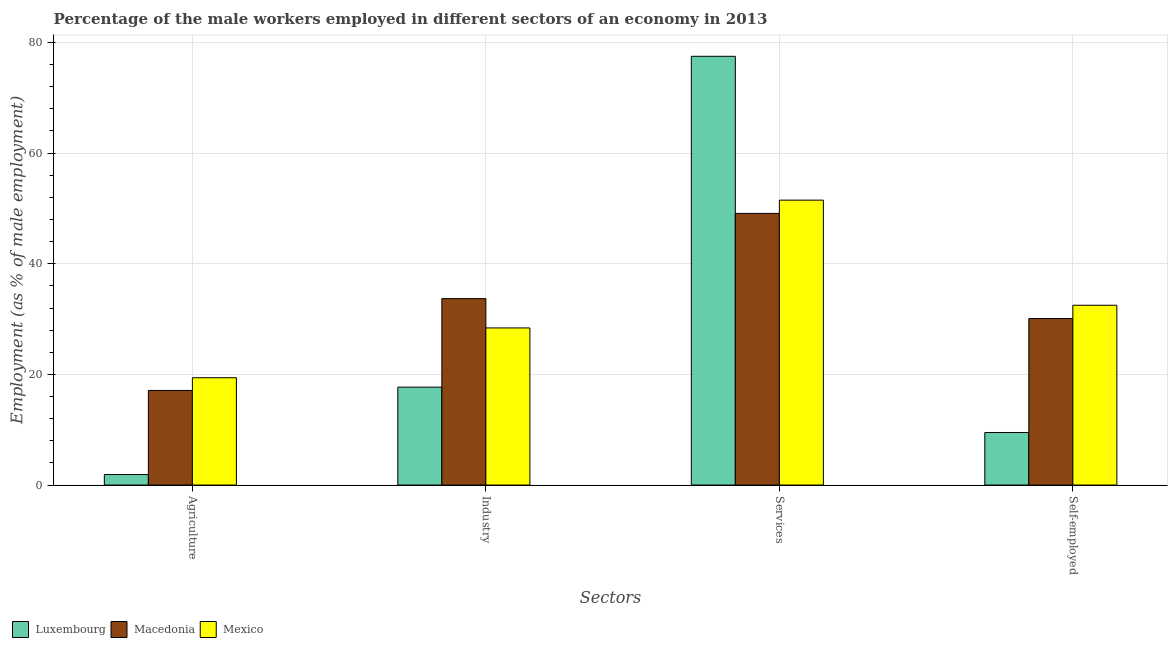How many different coloured bars are there?
Provide a short and direct response. 3. Are the number of bars per tick equal to the number of legend labels?
Your response must be concise. Yes. What is the label of the 2nd group of bars from the left?
Provide a succinct answer. Industry. Across all countries, what is the maximum percentage of male workers in services?
Offer a terse response. 77.5. Across all countries, what is the minimum percentage of male workers in services?
Offer a very short reply. 49.1. In which country was the percentage of male workers in services maximum?
Your response must be concise. Luxembourg. In which country was the percentage of self employed male workers minimum?
Provide a short and direct response. Luxembourg. What is the total percentage of male workers in services in the graph?
Provide a succinct answer. 178.1. What is the difference between the percentage of male workers in services in Luxembourg and that in Mexico?
Offer a very short reply. 26. What is the difference between the percentage of male workers in industry in Mexico and the percentage of male workers in services in Luxembourg?
Your answer should be very brief. -49.1. What is the average percentage of male workers in agriculture per country?
Provide a short and direct response. 12.8. What is the difference between the percentage of self employed male workers and percentage of male workers in industry in Luxembourg?
Offer a terse response. -8.2. In how many countries, is the percentage of male workers in agriculture greater than 40 %?
Give a very brief answer. 0. What is the ratio of the percentage of male workers in agriculture in Luxembourg to that in Macedonia?
Your answer should be compact. 0.11. Is the percentage of self employed male workers in Macedonia less than that in Mexico?
Offer a terse response. Yes. Is the difference between the percentage of male workers in services in Macedonia and Mexico greater than the difference between the percentage of male workers in agriculture in Macedonia and Mexico?
Provide a short and direct response. No. What is the difference between the highest and the second highest percentage of self employed male workers?
Ensure brevity in your answer.  2.4. What is the difference between the highest and the lowest percentage of male workers in industry?
Offer a very short reply. 16. Is the sum of the percentage of male workers in industry in Mexico and Macedonia greater than the maximum percentage of male workers in services across all countries?
Make the answer very short. No. Is it the case that in every country, the sum of the percentage of self employed male workers and percentage of male workers in agriculture is greater than the sum of percentage of male workers in services and percentage of male workers in industry?
Your answer should be compact. No. What does the 2nd bar from the left in Industry represents?
Your answer should be compact. Macedonia. What does the 3rd bar from the right in Agriculture represents?
Offer a very short reply. Luxembourg. Is it the case that in every country, the sum of the percentage of male workers in agriculture and percentage of male workers in industry is greater than the percentage of male workers in services?
Your answer should be compact. No. Are all the bars in the graph horizontal?
Give a very brief answer. No. How many countries are there in the graph?
Make the answer very short. 3. What is the difference between two consecutive major ticks on the Y-axis?
Ensure brevity in your answer.  20. Does the graph contain any zero values?
Give a very brief answer. No. How many legend labels are there?
Provide a short and direct response. 3. How are the legend labels stacked?
Your response must be concise. Horizontal. What is the title of the graph?
Offer a terse response. Percentage of the male workers employed in different sectors of an economy in 2013. What is the label or title of the X-axis?
Provide a short and direct response. Sectors. What is the label or title of the Y-axis?
Your response must be concise. Employment (as % of male employment). What is the Employment (as % of male employment) in Luxembourg in Agriculture?
Provide a short and direct response. 1.9. What is the Employment (as % of male employment) of Macedonia in Agriculture?
Offer a very short reply. 17.1. What is the Employment (as % of male employment) in Mexico in Agriculture?
Ensure brevity in your answer.  19.4. What is the Employment (as % of male employment) in Luxembourg in Industry?
Make the answer very short. 17.7. What is the Employment (as % of male employment) of Macedonia in Industry?
Make the answer very short. 33.7. What is the Employment (as % of male employment) of Mexico in Industry?
Your answer should be very brief. 28.4. What is the Employment (as % of male employment) in Luxembourg in Services?
Give a very brief answer. 77.5. What is the Employment (as % of male employment) in Macedonia in Services?
Give a very brief answer. 49.1. What is the Employment (as % of male employment) of Mexico in Services?
Offer a very short reply. 51.5. What is the Employment (as % of male employment) in Luxembourg in Self-employed?
Offer a very short reply. 9.5. What is the Employment (as % of male employment) in Macedonia in Self-employed?
Offer a terse response. 30.1. What is the Employment (as % of male employment) in Mexico in Self-employed?
Your response must be concise. 32.5. Across all Sectors, what is the maximum Employment (as % of male employment) in Luxembourg?
Ensure brevity in your answer.  77.5. Across all Sectors, what is the maximum Employment (as % of male employment) of Macedonia?
Keep it short and to the point. 49.1. Across all Sectors, what is the maximum Employment (as % of male employment) of Mexico?
Make the answer very short. 51.5. Across all Sectors, what is the minimum Employment (as % of male employment) in Luxembourg?
Ensure brevity in your answer.  1.9. Across all Sectors, what is the minimum Employment (as % of male employment) of Macedonia?
Ensure brevity in your answer.  17.1. Across all Sectors, what is the minimum Employment (as % of male employment) in Mexico?
Your response must be concise. 19.4. What is the total Employment (as % of male employment) in Luxembourg in the graph?
Keep it short and to the point. 106.6. What is the total Employment (as % of male employment) of Macedonia in the graph?
Provide a succinct answer. 130. What is the total Employment (as % of male employment) in Mexico in the graph?
Make the answer very short. 131.8. What is the difference between the Employment (as % of male employment) of Luxembourg in Agriculture and that in Industry?
Your answer should be compact. -15.8. What is the difference between the Employment (as % of male employment) in Macedonia in Agriculture and that in Industry?
Your answer should be very brief. -16.6. What is the difference between the Employment (as % of male employment) of Luxembourg in Agriculture and that in Services?
Provide a short and direct response. -75.6. What is the difference between the Employment (as % of male employment) of Macedonia in Agriculture and that in Services?
Provide a short and direct response. -32. What is the difference between the Employment (as % of male employment) in Mexico in Agriculture and that in Services?
Keep it short and to the point. -32.1. What is the difference between the Employment (as % of male employment) in Macedonia in Agriculture and that in Self-employed?
Make the answer very short. -13. What is the difference between the Employment (as % of male employment) in Luxembourg in Industry and that in Services?
Keep it short and to the point. -59.8. What is the difference between the Employment (as % of male employment) of Macedonia in Industry and that in Services?
Your response must be concise. -15.4. What is the difference between the Employment (as % of male employment) of Mexico in Industry and that in Services?
Your response must be concise. -23.1. What is the difference between the Employment (as % of male employment) of Luxembourg in Industry and that in Self-employed?
Offer a very short reply. 8.2. What is the difference between the Employment (as % of male employment) in Macedonia in Industry and that in Self-employed?
Ensure brevity in your answer.  3.6. What is the difference between the Employment (as % of male employment) in Luxembourg in Services and that in Self-employed?
Your response must be concise. 68. What is the difference between the Employment (as % of male employment) in Mexico in Services and that in Self-employed?
Your response must be concise. 19. What is the difference between the Employment (as % of male employment) of Luxembourg in Agriculture and the Employment (as % of male employment) of Macedonia in Industry?
Your answer should be very brief. -31.8. What is the difference between the Employment (as % of male employment) of Luxembourg in Agriculture and the Employment (as % of male employment) of Mexico in Industry?
Ensure brevity in your answer.  -26.5. What is the difference between the Employment (as % of male employment) of Macedonia in Agriculture and the Employment (as % of male employment) of Mexico in Industry?
Offer a very short reply. -11.3. What is the difference between the Employment (as % of male employment) in Luxembourg in Agriculture and the Employment (as % of male employment) in Macedonia in Services?
Your answer should be compact. -47.2. What is the difference between the Employment (as % of male employment) in Luxembourg in Agriculture and the Employment (as % of male employment) in Mexico in Services?
Give a very brief answer. -49.6. What is the difference between the Employment (as % of male employment) in Macedonia in Agriculture and the Employment (as % of male employment) in Mexico in Services?
Ensure brevity in your answer.  -34.4. What is the difference between the Employment (as % of male employment) in Luxembourg in Agriculture and the Employment (as % of male employment) in Macedonia in Self-employed?
Provide a short and direct response. -28.2. What is the difference between the Employment (as % of male employment) of Luxembourg in Agriculture and the Employment (as % of male employment) of Mexico in Self-employed?
Provide a succinct answer. -30.6. What is the difference between the Employment (as % of male employment) of Macedonia in Agriculture and the Employment (as % of male employment) of Mexico in Self-employed?
Your answer should be very brief. -15.4. What is the difference between the Employment (as % of male employment) of Luxembourg in Industry and the Employment (as % of male employment) of Macedonia in Services?
Provide a short and direct response. -31.4. What is the difference between the Employment (as % of male employment) of Luxembourg in Industry and the Employment (as % of male employment) of Mexico in Services?
Ensure brevity in your answer.  -33.8. What is the difference between the Employment (as % of male employment) in Macedonia in Industry and the Employment (as % of male employment) in Mexico in Services?
Your response must be concise. -17.8. What is the difference between the Employment (as % of male employment) of Luxembourg in Industry and the Employment (as % of male employment) of Macedonia in Self-employed?
Offer a very short reply. -12.4. What is the difference between the Employment (as % of male employment) in Luxembourg in Industry and the Employment (as % of male employment) in Mexico in Self-employed?
Offer a terse response. -14.8. What is the difference between the Employment (as % of male employment) in Macedonia in Industry and the Employment (as % of male employment) in Mexico in Self-employed?
Your response must be concise. 1.2. What is the difference between the Employment (as % of male employment) of Luxembourg in Services and the Employment (as % of male employment) of Macedonia in Self-employed?
Your answer should be very brief. 47.4. What is the difference between the Employment (as % of male employment) of Luxembourg in Services and the Employment (as % of male employment) of Mexico in Self-employed?
Give a very brief answer. 45. What is the average Employment (as % of male employment) in Luxembourg per Sectors?
Ensure brevity in your answer.  26.65. What is the average Employment (as % of male employment) of Macedonia per Sectors?
Provide a succinct answer. 32.5. What is the average Employment (as % of male employment) of Mexico per Sectors?
Your response must be concise. 32.95. What is the difference between the Employment (as % of male employment) of Luxembourg and Employment (as % of male employment) of Macedonia in Agriculture?
Offer a very short reply. -15.2. What is the difference between the Employment (as % of male employment) of Luxembourg and Employment (as % of male employment) of Mexico in Agriculture?
Make the answer very short. -17.5. What is the difference between the Employment (as % of male employment) in Luxembourg and Employment (as % of male employment) in Mexico in Industry?
Keep it short and to the point. -10.7. What is the difference between the Employment (as % of male employment) of Macedonia and Employment (as % of male employment) of Mexico in Industry?
Your answer should be very brief. 5.3. What is the difference between the Employment (as % of male employment) of Luxembourg and Employment (as % of male employment) of Macedonia in Services?
Your response must be concise. 28.4. What is the difference between the Employment (as % of male employment) in Macedonia and Employment (as % of male employment) in Mexico in Services?
Provide a succinct answer. -2.4. What is the difference between the Employment (as % of male employment) of Luxembourg and Employment (as % of male employment) of Macedonia in Self-employed?
Provide a succinct answer. -20.6. What is the difference between the Employment (as % of male employment) of Macedonia and Employment (as % of male employment) of Mexico in Self-employed?
Keep it short and to the point. -2.4. What is the ratio of the Employment (as % of male employment) in Luxembourg in Agriculture to that in Industry?
Offer a terse response. 0.11. What is the ratio of the Employment (as % of male employment) of Macedonia in Agriculture to that in Industry?
Offer a very short reply. 0.51. What is the ratio of the Employment (as % of male employment) in Mexico in Agriculture to that in Industry?
Offer a very short reply. 0.68. What is the ratio of the Employment (as % of male employment) in Luxembourg in Agriculture to that in Services?
Ensure brevity in your answer.  0.02. What is the ratio of the Employment (as % of male employment) in Macedonia in Agriculture to that in Services?
Give a very brief answer. 0.35. What is the ratio of the Employment (as % of male employment) of Mexico in Agriculture to that in Services?
Your answer should be compact. 0.38. What is the ratio of the Employment (as % of male employment) of Macedonia in Agriculture to that in Self-employed?
Give a very brief answer. 0.57. What is the ratio of the Employment (as % of male employment) in Mexico in Agriculture to that in Self-employed?
Your response must be concise. 0.6. What is the ratio of the Employment (as % of male employment) in Luxembourg in Industry to that in Services?
Your answer should be compact. 0.23. What is the ratio of the Employment (as % of male employment) of Macedonia in Industry to that in Services?
Keep it short and to the point. 0.69. What is the ratio of the Employment (as % of male employment) of Mexico in Industry to that in Services?
Keep it short and to the point. 0.55. What is the ratio of the Employment (as % of male employment) in Luxembourg in Industry to that in Self-employed?
Ensure brevity in your answer.  1.86. What is the ratio of the Employment (as % of male employment) of Macedonia in Industry to that in Self-employed?
Ensure brevity in your answer.  1.12. What is the ratio of the Employment (as % of male employment) of Mexico in Industry to that in Self-employed?
Provide a succinct answer. 0.87. What is the ratio of the Employment (as % of male employment) in Luxembourg in Services to that in Self-employed?
Keep it short and to the point. 8.16. What is the ratio of the Employment (as % of male employment) of Macedonia in Services to that in Self-employed?
Offer a very short reply. 1.63. What is the ratio of the Employment (as % of male employment) in Mexico in Services to that in Self-employed?
Your response must be concise. 1.58. What is the difference between the highest and the second highest Employment (as % of male employment) in Luxembourg?
Keep it short and to the point. 59.8. What is the difference between the highest and the second highest Employment (as % of male employment) of Macedonia?
Offer a terse response. 15.4. What is the difference between the highest and the second highest Employment (as % of male employment) of Mexico?
Offer a very short reply. 19. What is the difference between the highest and the lowest Employment (as % of male employment) in Luxembourg?
Provide a short and direct response. 75.6. What is the difference between the highest and the lowest Employment (as % of male employment) in Macedonia?
Provide a succinct answer. 32. What is the difference between the highest and the lowest Employment (as % of male employment) in Mexico?
Make the answer very short. 32.1. 